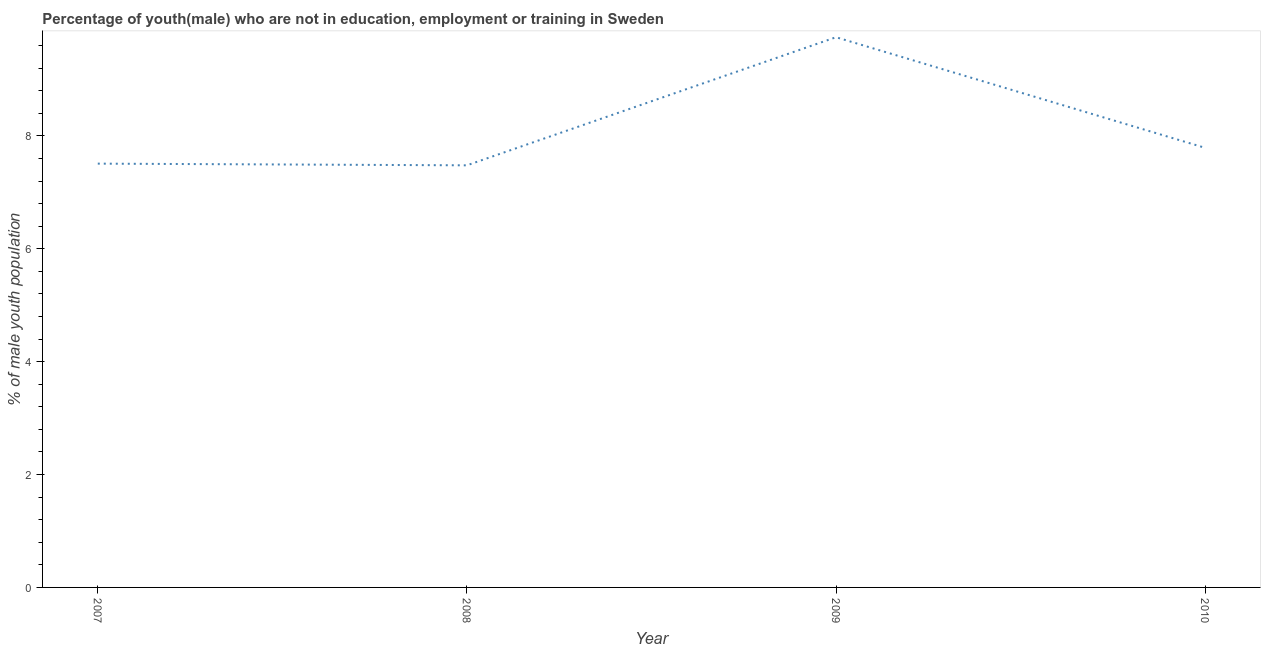What is the unemployed male youth population in 2008?
Offer a very short reply. 7.48. Across all years, what is the maximum unemployed male youth population?
Provide a succinct answer. 9.75. Across all years, what is the minimum unemployed male youth population?
Provide a short and direct response. 7.48. In which year was the unemployed male youth population maximum?
Keep it short and to the point. 2009. What is the sum of the unemployed male youth population?
Ensure brevity in your answer.  32.53. What is the difference between the unemployed male youth population in 2007 and 2009?
Your response must be concise. -2.24. What is the average unemployed male youth population per year?
Ensure brevity in your answer.  8.13. What is the median unemployed male youth population?
Provide a succinct answer. 7.65. In how many years, is the unemployed male youth population greater than 4 %?
Your answer should be very brief. 4. Do a majority of the years between 2009 and 2008 (inclusive) have unemployed male youth population greater than 8.8 %?
Your answer should be compact. No. What is the ratio of the unemployed male youth population in 2007 to that in 2010?
Your answer should be very brief. 0.96. What is the difference between the highest and the second highest unemployed male youth population?
Your response must be concise. 1.96. Is the sum of the unemployed male youth population in 2007 and 2009 greater than the maximum unemployed male youth population across all years?
Offer a very short reply. Yes. What is the difference between the highest and the lowest unemployed male youth population?
Offer a terse response. 2.27. In how many years, is the unemployed male youth population greater than the average unemployed male youth population taken over all years?
Keep it short and to the point. 1. Does the unemployed male youth population monotonically increase over the years?
Offer a terse response. No. How many lines are there?
Provide a succinct answer. 1. How many years are there in the graph?
Offer a terse response. 4. What is the difference between two consecutive major ticks on the Y-axis?
Offer a very short reply. 2. Are the values on the major ticks of Y-axis written in scientific E-notation?
Offer a very short reply. No. Does the graph contain grids?
Your response must be concise. No. What is the title of the graph?
Offer a terse response. Percentage of youth(male) who are not in education, employment or training in Sweden. What is the label or title of the Y-axis?
Provide a succinct answer. % of male youth population. What is the % of male youth population of 2007?
Your response must be concise. 7.51. What is the % of male youth population in 2008?
Make the answer very short. 7.48. What is the % of male youth population in 2009?
Make the answer very short. 9.75. What is the % of male youth population of 2010?
Provide a succinct answer. 7.79. What is the difference between the % of male youth population in 2007 and 2008?
Your response must be concise. 0.03. What is the difference between the % of male youth population in 2007 and 2009?
Make the answer very short. -2.24. What is the difference between the % of male youth population in 2007 and 2010?
Offer a very short reply. -0.28. What is the difference between the % of male youth population in 2008 and 2009?
Offer a very short reply. -2.27. What is the difference between the % of male youth population in 2008 and 2010?
Give a very brief answer. -0.31. What is the difference between the % of male youth population in 2009 and 2010?
Keep it short and to the point. 1.96. What is the ratio of the % of male youth population in 2007 to that in 2009?
Keep it short and to the point. 0.77. What is the ratio of the % of male youth population in 2008 to that in 2009?
Offer a terse response. 0.77. What is the ratio of the % of male youth population in 2008 to that in 2010?
Your answer should be compact. 0.96. What is the ratio of the % of male youth population in 2009 to that in 2010?
Offer a very short reply. 1.25. 